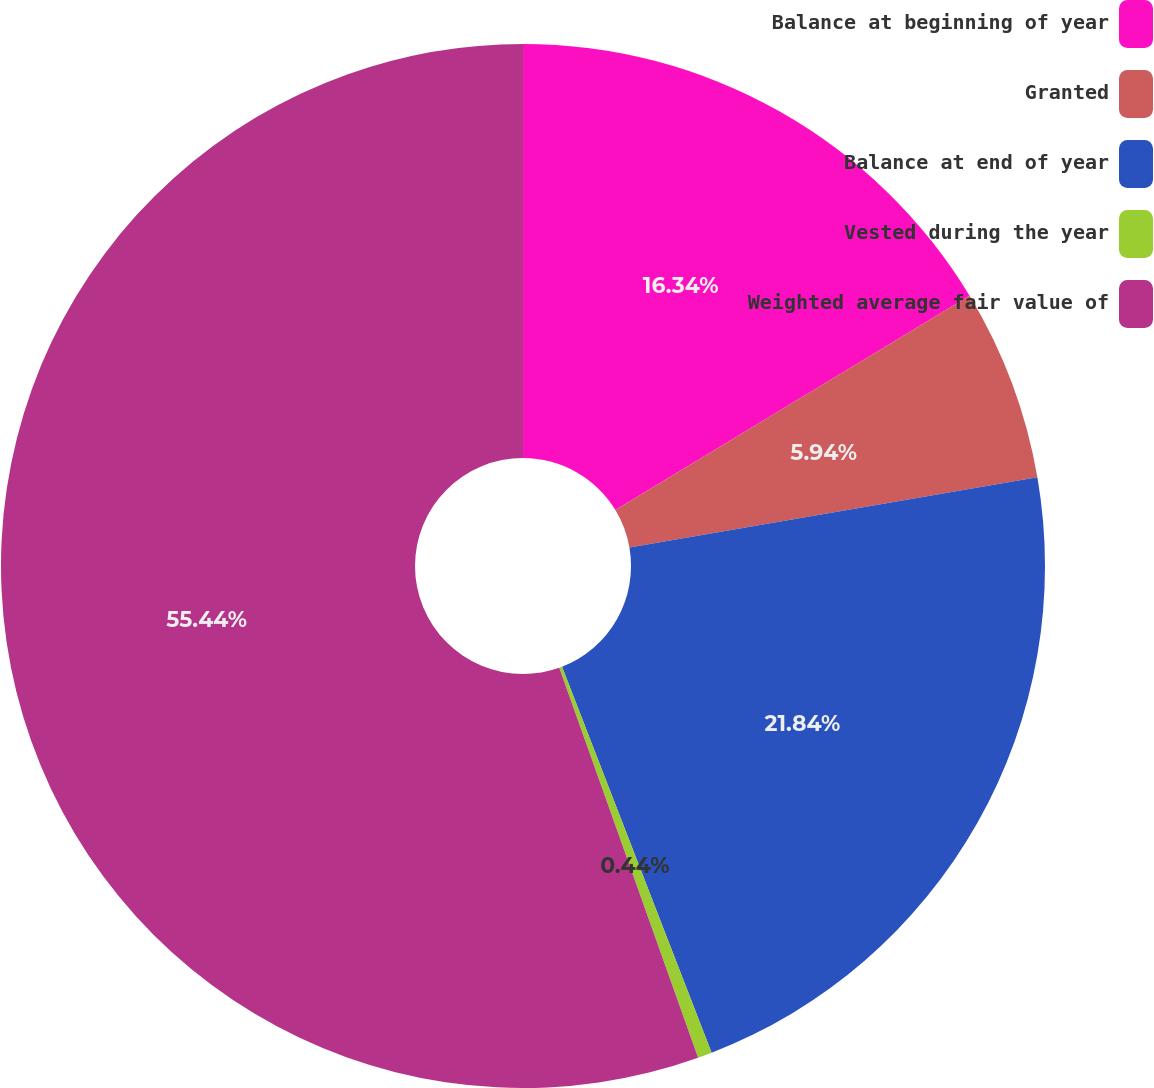Convert chart. <chart><loc_0><loc_0><loc_500><loc_500><pie_chart><fcel>Balance at beginning of year<fcel>Granted<fcel>Balance at end of year<fcel>Vested during the year<fcel>Weighted average fair value of<nl><fcel>16.34%<fcel>5.94%<fcel>21.84%<fcel>0.44%<fcel>55.45%<nl></chart> 